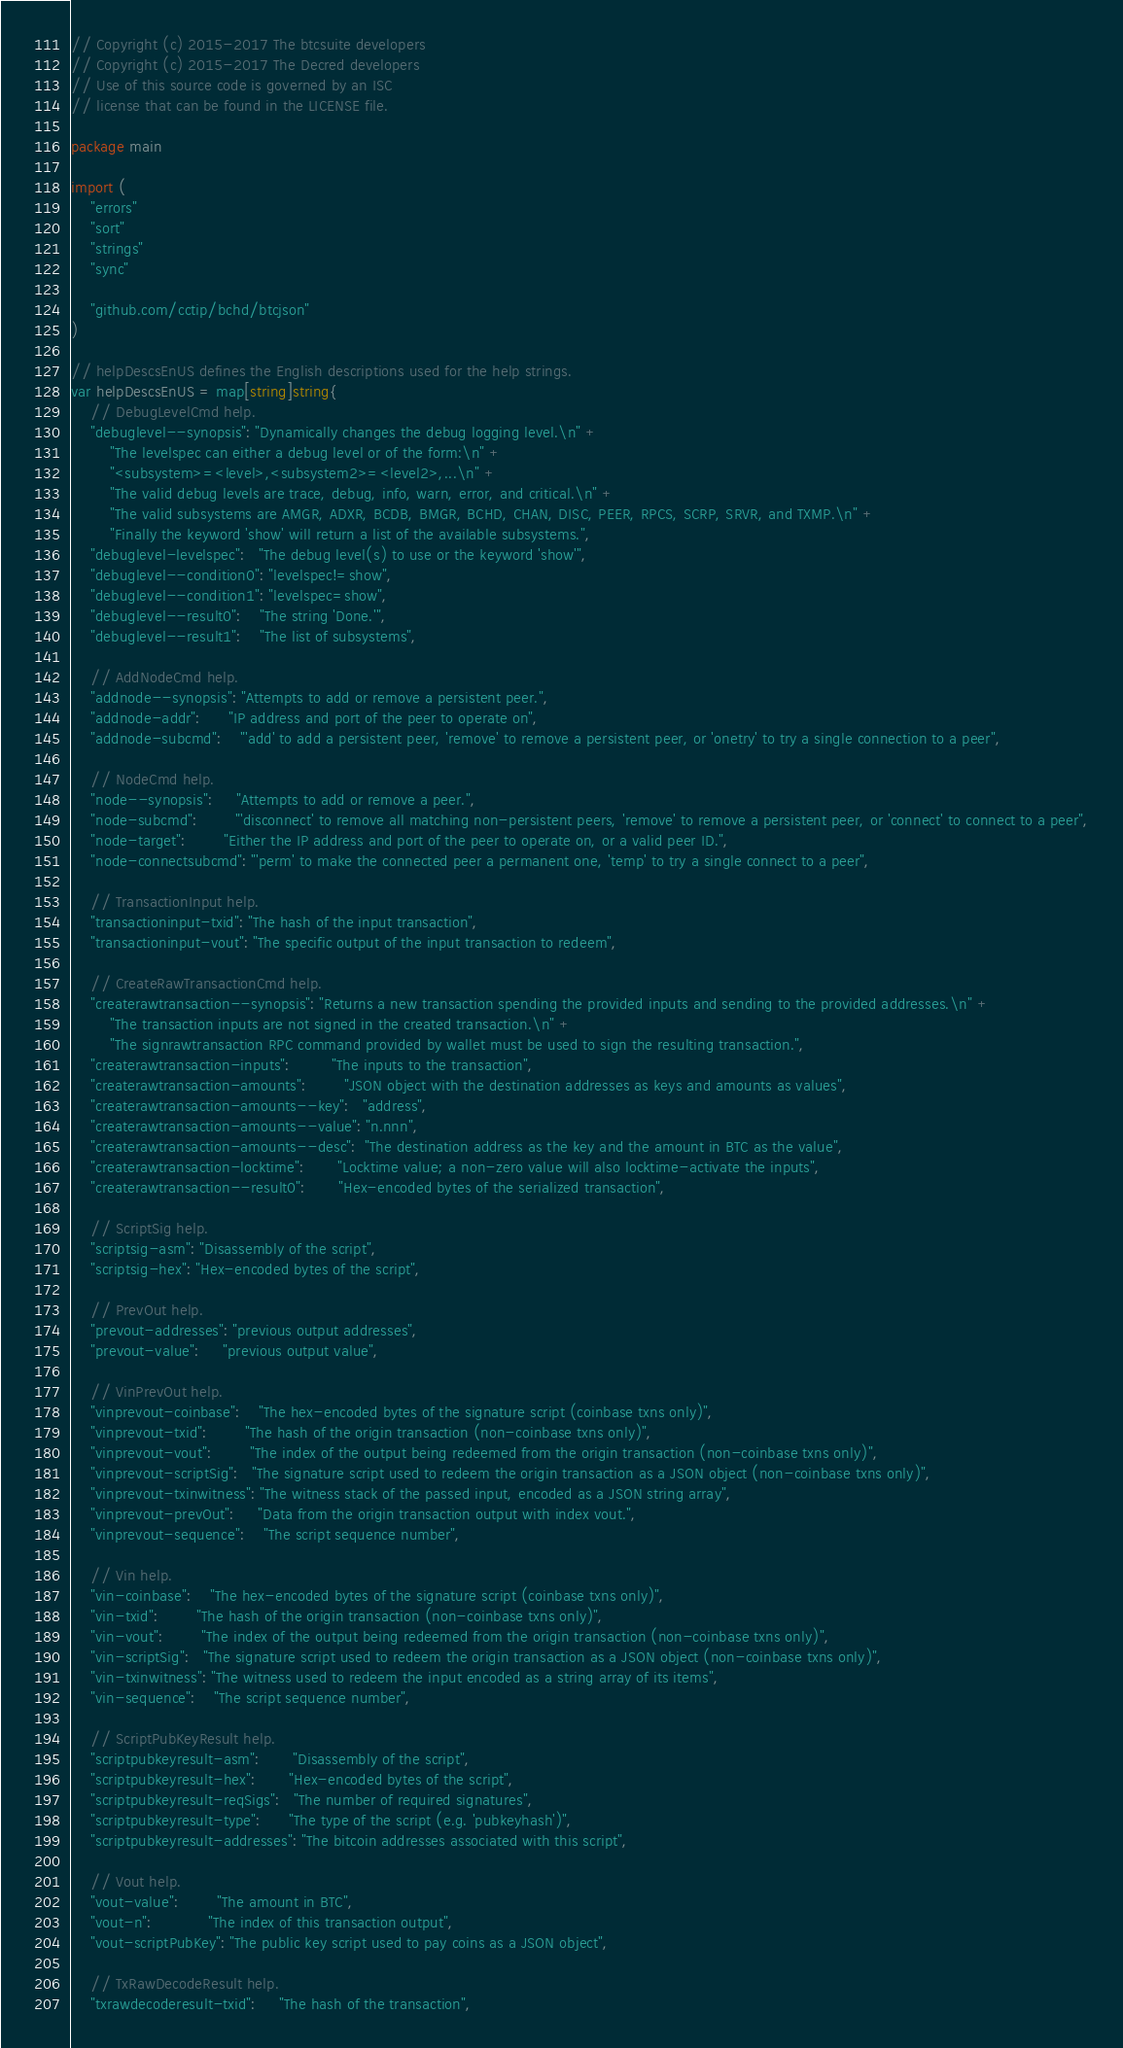<code> <loc_0><loc_0><loc_500><loc_500><_Go_>// Copyright (c) 2015-2017 The btcsuite developers
// Copyright (c) 2015-2017 The Decred developers
// Use of this source code is governed by an ISC
// license that can be found in the LICENSE file.

package main

import (
	"errors"
	"sort"
	"strings"
	"sync"

	"github.com/cctip/bchd/btcjson"
)

// helpDescsEnUS defines the English descriptions used for the help strings.
var helpDescsEnUS = map[string]string{
	// DebugLevelCmd help.
	"debuglevel--synopsis": "Dynamically changes the debug logging level.\n" +
		"The levelspec can either a debug level or of the form:\n" +
		"<subsystem>=<level>,<subsystem2>=<level2>,...\n" +
		"The valid debug levels are trace, debug, info, warn, error, and critical.\n" +
		"The valid subsystems are AMGR, ADXR, BCDB, BMGR, BCHD, CHAN, DISC, PEER, RPCS, SCRP, SRVR, and TXMP.\n" +
		"Finally the keyword 'show' will return a list of the available subsystems.",
	"debuglevel-levelspec":   "The debug level(s) to use or the keyword 'show'",
	"debuglevel--condition0": "levelspec!=show",
	"debuglevel--condition1": "levelspec=show",
	"debuglevel--result0":    "The string 'Done.'",
	"debuglevel--result1":    "The list of subsystems",

	// AddNodeCmd help.
	"addnode--synopsis": "Attempts to add or remove a persistent peer.",
	"addnode-addr":      "IP address and port of the peer to operate on",
	"addnode-subcmd":    "'add' to add a persistent peer, 'remove' to remove a persistent peer, or 'onetry' to try a single connection to a peer",

	// NodeCmd help.
	"node--synopsis":     "Attempts to add or remove a peer.",
	"node-subcmd":        "'disconnect' to remove all matching non-persistent peers, 'remove' to remove a persistent peer, or 'connect' to connect to a peer",
	"node-target":        "Either the IP address and port of the peer to operate on, or a valid peer ID.",
	"node-connectsubcmd": "'perm' to make the connected peer a permanent one, 'temp' to try a single connect to a peer",

	// TransactionInput help.
	"transactioninput-txid": "The hash of the input transaction",
	"transactioninput-vout": "The specific output of the input transaction to redeem",

	// CreateRawTransactionCmd help.
	"createrawtransaction--synopsis": "Returns a new transaction spending the provided inputs and sending to the provided addresses.\n" +
		"The transaction inputs are not signed in the created transaction.\n" +
		"The signrawtransaction RPC command provided by wallet must be used to sign the resulting transaction.",
	"createrawtransaction-inputs":         "The inputs to the transaction",
	"createrawtransaction-amounts":        "JSON object with the destination addresses as keys and amounts as values",
	"createrawtransaction-amounts--key":   "address",
	"createrawtransaction-amounts--value": "n.nnn",
	"createrawtransaction-amounts--desc":  "The destination address as the key and the amount in BTC as the value",
	"createrawtransaction-locktime":       "Locktime value; a non-zero value will also locktime-activate the inputs",
	"createrawtransaction--result0":       "Hex-encoded bytes of the serialized transaction",

	// ScriptSig help.
	"scriptsig-asm": "Disassembly of the script",
	"scriptsig-hex": "Hex-encoded bytes of the script",

	// PrevOut help.
	"prevout-addresses": "previous output addresses",
	"prevout-value":     "previous output value",

	// VinPrevOut help.
	"vinprevout-coinbase":    "The hex-encoded bytes of the signature script (coinbase txns only)",
	"vinprevout-txid":        "The hash of the origin transaction (non-coinbase txns only)",
	"vinprevout-vout":        "The index of the output being redeemed from the origin transaction (non-coinbase txns only)",
	"vinprevout-scriptSig":   "The signature script used to redeem the origin transaction as a JSON object (non-coinbase txns only)",
	"vinprevout-txinwitness": "The witness stack of the passed input, encoded as a JSON string array",
	"vinprevout-prevOut":     "Data from the origin transaction output with index vout.",
	"vinprevout-sequence":    "The script sequence number",

	// Vin help.
	"vin-coinbase":    "The hex-encoded bytes of the signature script (coinbase txns only)",
	"vin-txid":        "The hash of the origin transaction (non-coinbase txns only)",
	"vin-vout":        "The index of the output being redeemed from the origin transaction (non-coinbase txns only)",
	"vin-scriptSig":   "The signature script used to redeem the origin transaction as a JSON object (non-coinbase txns only)",
	"vin-txinwitness": "The witness used to redeem the input encoded as a string array of its items",
	"vin-sequence":    "The script sequence number",

	// ScriptPubKeyResult help.
	"scriptpubkeyresult-asm":       "Disassembly of the script",
	"scriptpubkeyresult-hex":       "Hex-encoded bytes of the script",
	"scriptpubkeyresult-reqSigs":   "The number of required signatures",
	"scriptpubkeyresult-type":      "The type of the script (e.g. 'pubkeyhash')",
	"scriptpubkeyresult-addresses": "The bitcoin addresses associated with this script",

	// Vout help.
	"vout-value":        "The amount in BTC",
	"vout-n":            "The index of this transaction output",
	"vout-scriptPubKey": "The public key script used to pay coins as a JSON object",

	// TxRawDecodeResult help.
	"txrawdecoderesult-txid":     "The hash of the transaction",</code> 